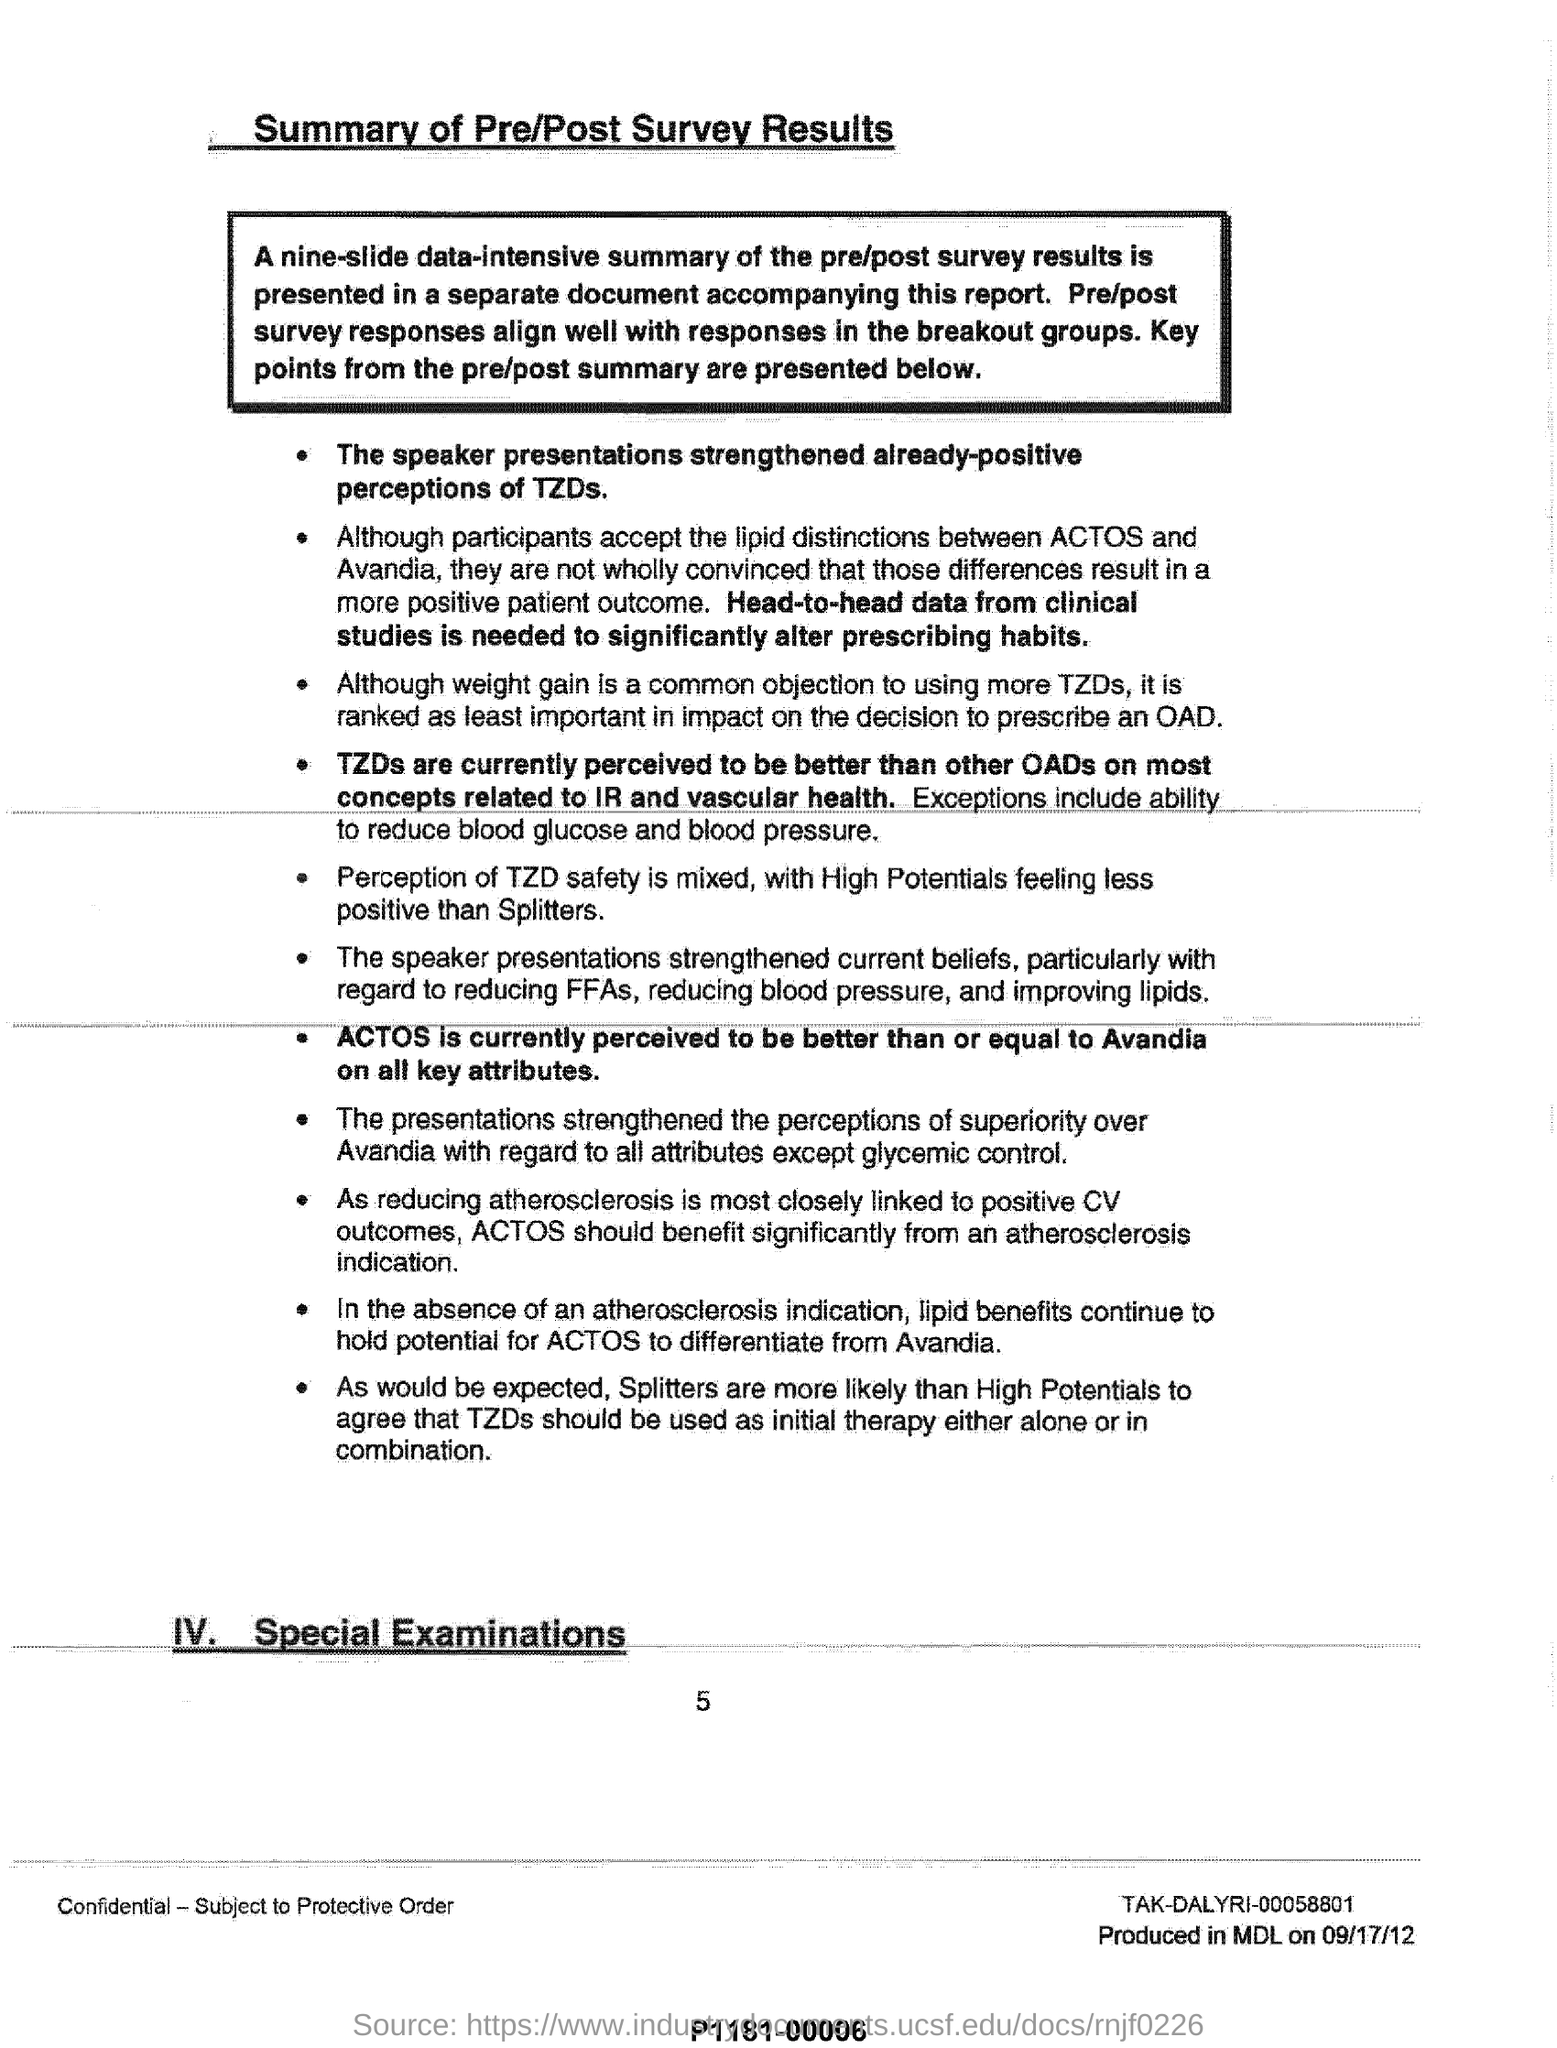Give some essential details in this illustration. The data that would significantly alter prescribing habits is head-to-head data from clinical studies. The speaker presentations have strengthened the already positive perceptions of TZDs. ACTOS is currently perceived to be better than or equal to Avandia on all key attributes. 